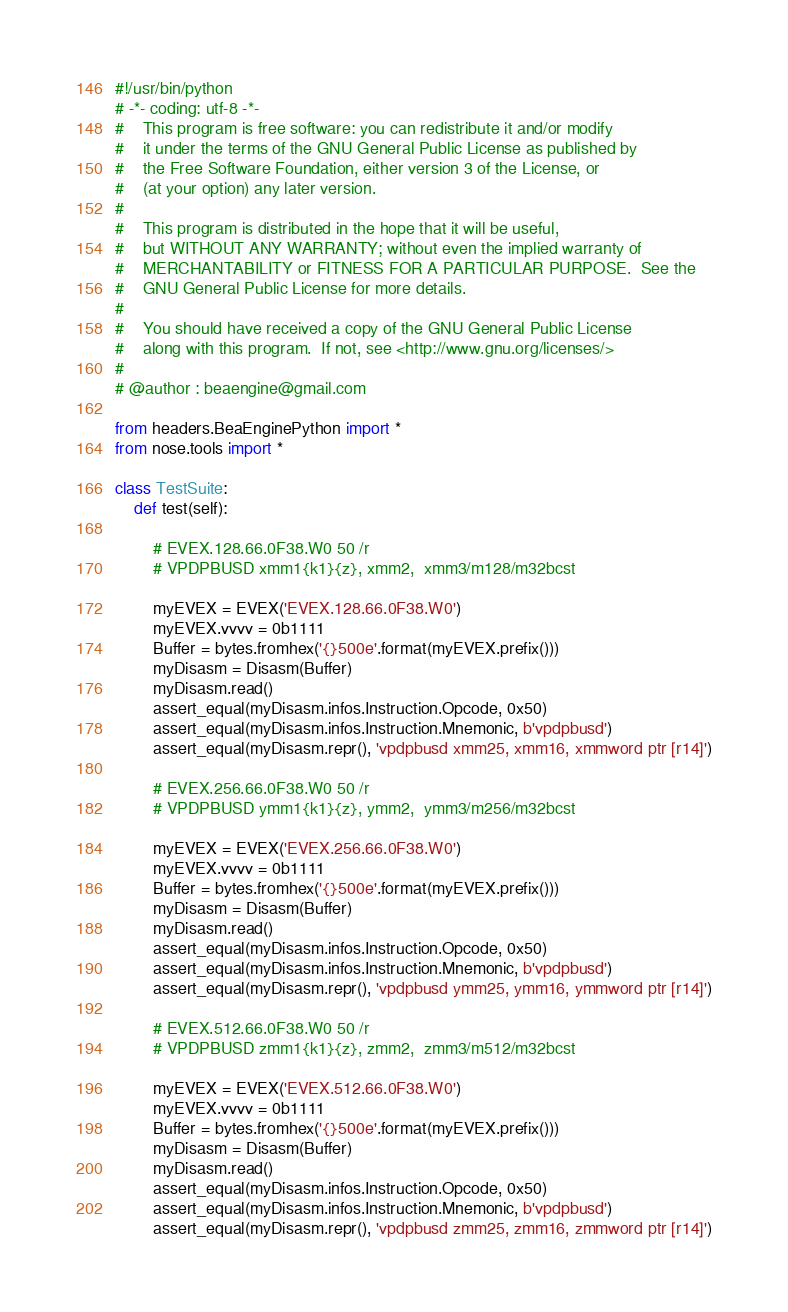<code> <loc_0><loc_0><loc_500><loc_500><_Python_>#!/usr/bin/python
# -*- coding: utf-8 -*-
#    This program is free software: you can redistribute it and/or modify
#    it under the terms of the GNU General Public License as published by
#    the Free Software Foundation, either version 3 of the License, or
#    (at your option) any later version.
#
#    This program is distributed in the hope that it will be useful,
#    but WITHOUT ANY WARRANTY; without even the implied warranty of
#    MERCHANTABILITY or FITNESS FOR A PARTICULAR PURPOSE.  See the
#    GNU General Public License for more details.
#
#    You should have received a copy of the GNU General Public License
#    along with this program.  If not, see <http://www.gnu.org/licenses/>
#
# @author : beaengine@gmail.com

from headers.BeaEnginePython import *
from nose.tools import *

class TestSuite:
    def test(self):

        # EVEX.128.66.0F38.W0 50 /r
        # VPDPBUSD xmm1{k1}{z}, xmm2,  xmm3/m128/m32bcst

        myEVEX = EVEX('EVEX.128.66.0F38.W0')
        myEVEX.vvvv = 0b1111
        Buffer = bytes.fromhex('{}500e'.format(myEVEX.prefix()))
        myDisasm = Disasm(Buffer)
        myDisasm.read()
        assert_equal(myDisasm.infos.Instruction.Opcode, 0x50)
        assert_equal(myDisasm.infos.Instruction.Mnemonic, b'vpdpbusd')
        assert_equal(myDisasm.repr(), 'vpdpbusd xmm25, xmm16, xmmword ptr [r14]')

        # EVEX.256.66.0F38.W0 50 /r
        # VPDPBUSD ymm1{k1}{z}, ymm2,  ymm3/m256/m32bcst

        myEVEX = EVEX('EVEX.256.66.0F38.W0')
        myEVEX.vvvv = 0b1111
        Buffer = bytes.fromhex('{}500e'.format(myEVEX.prefix()))
        myDisasm = Disasm(Buffer)
        myDisasm.read()
        assert_equal(myDisasm.infos.Instruction.Opcode, 0x50)
        assert_equal(myDisasm.infos.Instruction.Mnemonic, b'vpdpbusd')
        assert_equal(myDisasm.repr(), 'vpdpbusd ymm25, ymm16, ymmword ptr [r14]')

        # EVEX.512.66.0F38.W0 50 /r
        # VPDPBUSD zmm1{k1}{z}, zmm2,  zmm3/m512/m32bcst

        myEVEX = EVEX('EVEX.512.66.0F38.W0')
        myEVEX.vvvv = 0b1111
        Buffer = bytes.fromhex('{}500e'.format(myEVEX.prefix()))
        myDisasm = Disasm(Buffer)
        myDisasm.read()
        assert_equal(myDisasm.infos.Instruction.Opcode, 0x50)
        assert_equal(myDisasm.infos.Instruction.Mnemonic, b'vpdpbusd')
        assert_equal(myDisasm.repr(), 'vpdpbusd zmm25, zmm16, zmmword ptr [r14]')
</code> 